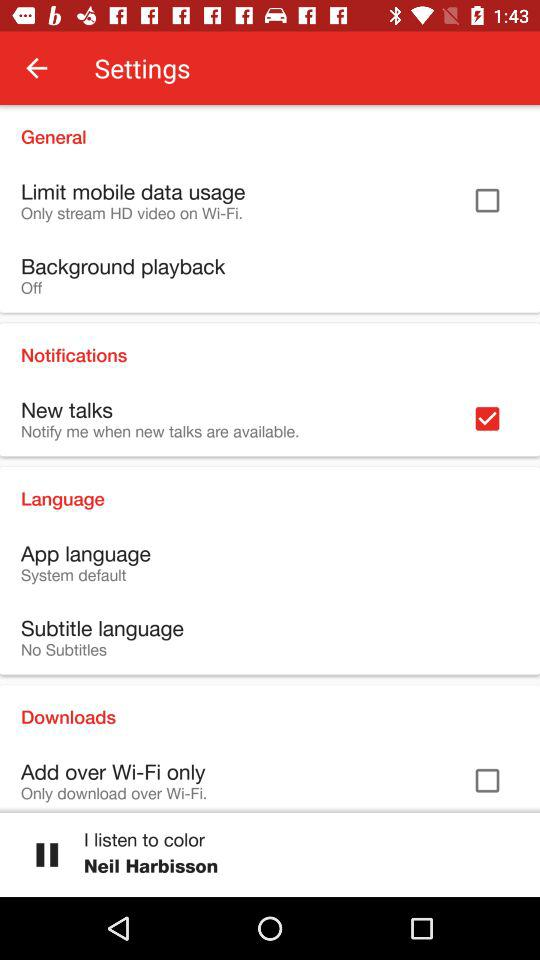What is the status of "Limit mobile data usage"? The status is "off". 